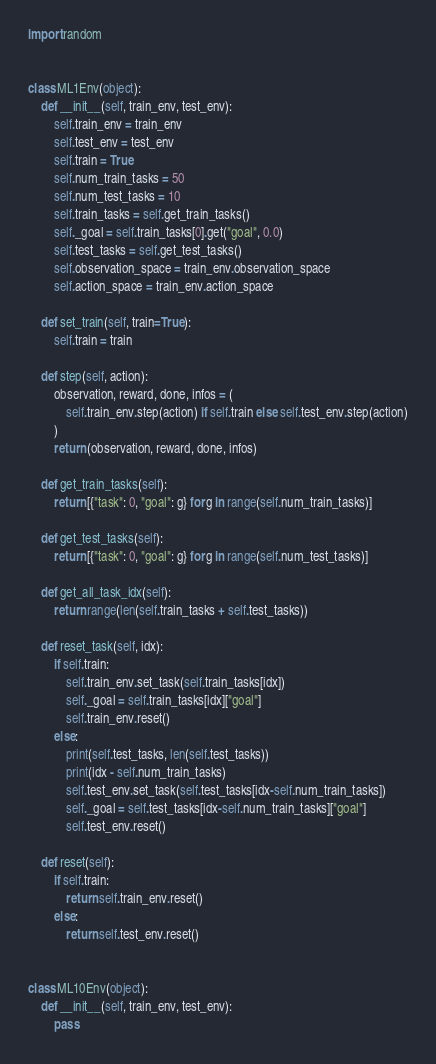<code> <loc_0><loc_0><loc_500><loc_500><_Python_>import random


class ML1Env(object):
    def __init__(self, train_env, test_env):
        self.train_env = train_env
        self.test_env = test_env
        self.train = True
        self.num_train_tasks = 50
        self.num_test_tasks = 10
        self.train_tasks = self.get_train_tasks()
        self._goal = self.train_tasks[0].get("goal", 0.0)
        self.test_tasks = self.get_test_tasks()
        self.observation_space = train_env.observation_space
        self.action_space = train_env.action_space

    def set_train(self, train=True):
        self.train = train

    def step(self, action):
        observation, reward, done, infos = (
            self.train_env.step(action) if self.train else self.test_env.step(action)
        )
        return (observation, reward, done, infos)

    def get_train_tasks(self):
        return [{"task": 0, "goal": g} for g in range(self.num_train_tasks)]

    def get_test_tasks(self):
        return [{"task": 0, "goal": g} for g in range(self.num_test_tasks)]

    def get_all_task_idx(self):
        return range(len(self.train_tasks + self.test_tasks))

    def reset_task(self, idx):
        if self.train:
            self.train_env.set_task(self.train_tasks[idx])
            self._goal = self.train_tasks[idx]["goal"]
            self.train_env.reset()
        else:
            print(self.test_tasks, len(self.test_tasks))
            print(idx - self.num_train_tasks)
            self.test_env.set_task(self.test_tasks[idx-self.num_train_tasks])
            self._goal = self.test_tasks[idx-self.num_train_tasks]["goal"]
            self.test_env.reset()

    def reset(self):
        if self.train:
            return self.train_env.reset()
        else:
            return self.test_env.reset()


class ML10Env(object):
    def __init__(self, train_env, test_env):
        pass

</code> 